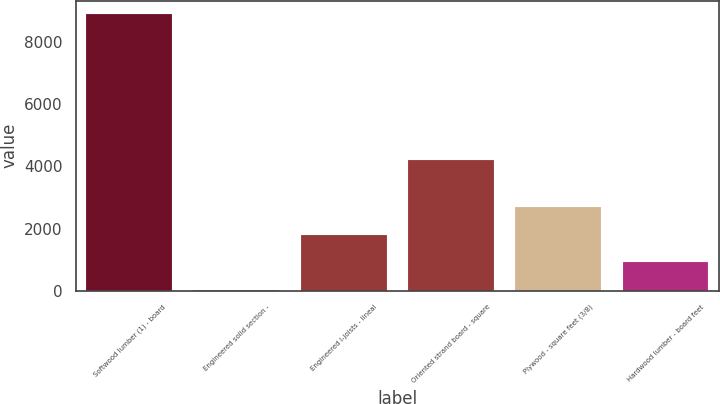Convert chart. <chart><loc_0><loc_0><loc_500><loc_500><bar_chart><fcel>Softwood lumber (1) - board<fcel>Engineered solid section -<fcel>Engineered I-joists - lineal<fcel>Oriented strand board - square<fcel>Plywood - square feet (3/8)<fcel>Hardwood lumber - board feet<nl><fcel>8890<fcel>37<fcel>1807.6<fcel>4213<fcel>2692.9<fcel>922.3<nl></chart> 